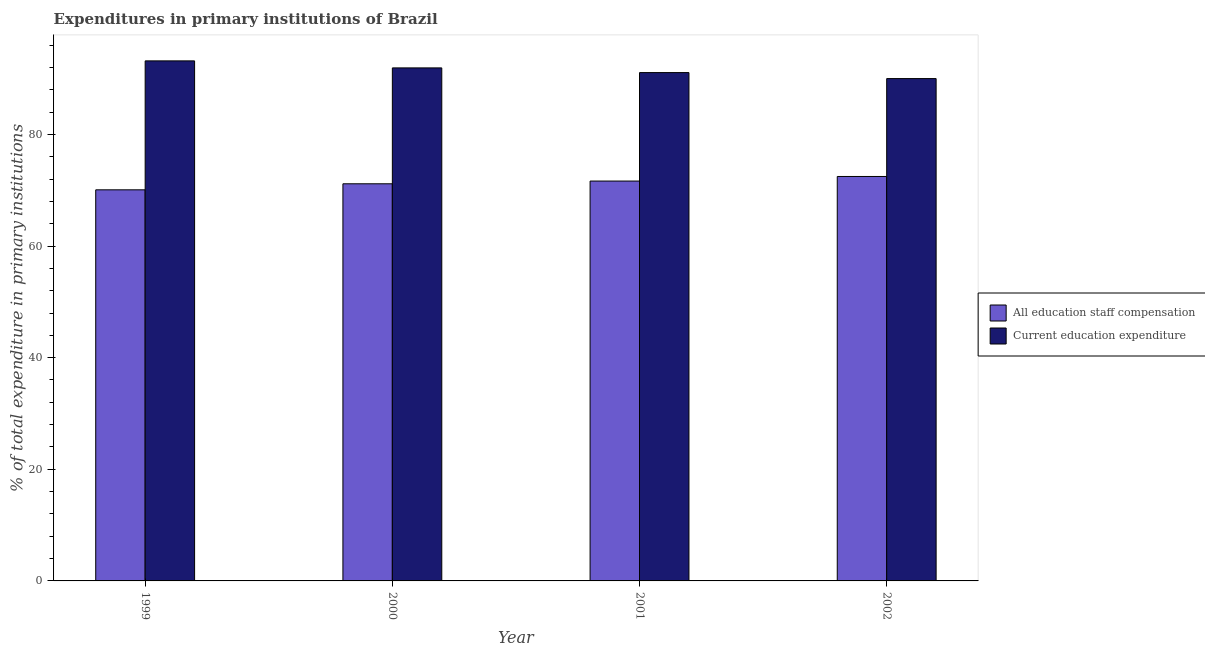Are the number of bars on each tick of the X-axis equal?
Keep it short and to the point. Yes. How many bars are there on the 3rd tick from the left?
Make the answer very short. 2. What is the expenditure in staff compensation in 2001?
Provide a short and direct response. 71.64. Across all years, what is the maximum expenditure in staff compensation?
Offer a terse response. 72.46. Across all years, what is the minimum expenditure in staff compensation?
Provide a short and direct response. 70.07. What is the total expenditure in education in the graph?
Make the answer very short. 366.17. What is the difference between the expenditure in staff compensation in 1999 and that in 2001?
Your answer should be very brief. -1.57. What is the difference between the expenditure in education in 2001 and the expenditure in staff compensation in 2002?
Give a very brief answer. 1.07. What is the average expenditure in education per year?
Provide a succinct answer. 91.54. In the year 2001, what is the difference between the expenditure in staff compensation and expenditure in education?
Your response must be concise. 0. In how many years, is the expenditure in staff compensation greater than 32 %?
Your answer should be very brief. 4. What is the ratio of the expenditure in education in 2000 to that in 2001?
Make the answer very short. 1.01. Is the expenditure in staff compensation in 1999 less than that in 2001?
Your answer should be very brief. Yes. What is the difference between the highest and the second highest expenditure in education?
Give a very brief answer. 1.26. What is the difference between the highest and the lowest expenditure in staff compensation?
Offer a very short reply. 2.39. What does the 1st bar from the left in 1999 represents?
Give a very brief answer. All education staff compensation. What does the 1st bar from the right in 2002 represents?
Your answer should be compact. Current education expenditure. Are all the bars in the graph horizontal?
Provide a short and direct response. No. What is the difference between two consecutive major ticks on the Y-axis?
Your answer should be compact. 20. Does the graph contain any zero values?
Provide a short and direct response. No. How many legend labels are there?
Give a very brief answer. 2. How are the legend labels stacked?
Your answer should be compact. Vertical. What is the title of the graph?
Provide a succinct answer. Expenditures in primary institutions of Brazil. What is the label or title of the Y-axis?
Your response must be concise. % of total expenditure in primary institutions. What is the % of total expenditure in primary institutions of All education staff compensation in 1999?
Your answer should be very brief. 70.07. What is the % of total expenditure in primary institutions of Current education expenditure in 1999?
Keep it short and to the point. 93.18. What is the % of total expenditure in primary institutions in All education staff compensation in 2000?
Provide a succinct answer. 71.15. What is the % of total expenditure in primary institutions of Current education expenditure in 2000?
Give a very brief answer. 91.92. What is the % of total expenditure in primary institutions of All education staff compensation in 2001?
Your answer should be very brief. 71.64. What is the % of total expenditure in primary institutions of Current education expenditure in 2001?
Your response must be concise. 91.08. What is the % of total expenditure in primary institutions in All education staff compensation in 2002?
Offer a very short reply. 72.46. What is the % of total expenditure in primary institutions of Current education expenditure in 2002?
Make the answer very short. 90. Across all years, what is the maximum % of total expenditure in primary institutions of All education staff compensation?
Provide a short and direct response. 72.46. Across all years, what is the maximum % of total expenditure in primary institutions of Current education expenditure?
Provide a short and direct response. 93.18. Across all years, what is the minimum % of total expenditure in primary institutions of All education staff compensation?
Offer a terse response. 70.07. Across all years, what is the minimum % of total expenditure in primary institutions of Current education expenditure?
Provide a short and direct response. 90. What is the total % of total expenditure in primary institutions of All education staff compensation in the graph?
Ensure brevity in your answer.  285.34. What is the total % of total expenditure in primary institutions of Current education expenditure in the graph?
Keep it short and to the point. 366.17. What is the difference between the % of total expenditure in primary institutions in All education staff compensation in 1999 and that in 2000?
Ensure brevity in your answer.  -1.08. What is the difference between the % of total expenditure in primary institutions of Current education expenditure in 1999 and that in 2000?
Provide a short and direct response. 1.26. What is the difference between the % of total expenditure in primary institutions in All education staff compensation in 1999 and that in 2001?
Your answer should be very brief. -1.57. What is the difference between the % of total expenditure in primary institutions of Current education expenditure in 1999 and that in 2001?
Give a very brief answer. 2.1. What is the difference between the % of total expenditure in primary institutions in All education staff compensation in 1999 and that in 2002?
Offer a terse response. -2.39. What is the difference between the % of total expenditure in primary institutions in Current education expenditure in 1999 and that in 2002?
Provide a succinct answer. 3.17. What is the difference between the % of total expenditure in primary institutions in All education staff compensation in 2000 and that in 2001?
Offer a very short reply. -0.49. What is the difference between the % of total expenditure in primary institutions in Current education expenditure in 2000 and that in 2001?
Ensure brevity in your answer.  0.84. What is the difference between the % of total expenditure in primary institutions in All education staff compensation in 2000 and that in 2002?
Provide a succinct answer. -1.31. What is the difference between the % of total expenditure in primary institutions of Current education expenditure in 2000 and that in 2002?
Keep it short and to the point. 1.91. What is the difference between the % of total expenditure in primary institutions of All education staff compensation in 2001 and that in 2002?
Your response must be concise. -0.82. What is the difference between the % of total expenditure in primary institutions in Current education expenditure in 2001 and that in 2002?
Provide a short and direct response. 1.07. What is the difference between the % of total expenditure in primary institutions of All education staff compensation in 1999 and the % of total expenditure in primary institutions of Current education expenditure in 2000?
Provide a succinct answer. -21.84. What is the difference between the % of total expenditure in primary institutions in All education staff compensation in 1999 and the % of total expenditure in primary institutions in Current education expenditure in 2001?
Your answer should be compact. -21. What is the difference between the % of total expenditure in primary institutions in All education staff compensation in 1999 and the % of total expenditure in primary institutions in Current education expenditure in 2002?
Provide a succinct answer. -19.93. What is the difference between the % of total expenditure in primary institutions in All education staff compensation in 2000 and the % of total expenditure in primary institutions in Current education expenditure in 2001?
Provide a succinct answer. -19.92. What is the difference between the % of total expenditure in primary institutions of All education staff compensation in 2000 and the % of total expenditure in primary institutions of Current education expenditure in 2002?
Provide a succinct answer. -18.85. What is the difference between the % of total expenditure in primary institutions of All education staff compensation in 2001 and the % of total expenditure in primary institutions of Current education expenditure in 2002?
Your answer should be compact. -18.36. What is the average % of total expenditure in primary institutions of All education staff compensation per year?
Provide a short and direct response. 71.33. What is the average % of total expenditure in primary institutions in Current education expenditure per year?
Your response must be concise. 91.54. In the year 1999, what is the difference between the % of total expenditure in primary institutions of All education staff compensation and % of total expenditure in primary institutions of Current education expenditure?
Your answer should be compact. -23.1. In the year 2000, what is the difference between the % of total expenditure in primary institutions of All education staff compensation and % of total expenditure in primary institutions of Current education expenditure?
Give a very brief answer. -20.76. In the year 2001, what is the difference between the % of total expenditure in primary institutions of All education staff compensation and % of total expenditure in primary institutions of Current education expenditure?
Offer a terse response. -19.43. In the year 2002, what is the difference between the % of total expenditure in primary institutions in All education staff compensation and % of total expenditure in primary institutions in Current education expenditure?
Make the answer very short. -17.54. What is the ratio of the % of total expenditure in primary institutions of Current education expenditure in 1999 to that in 2000?
Give a very brief answer. 1.01. What is the ratio of the % of total expenditure in primary institutions of All education staff compensation in 1999 to that in 2001?
Your answer should be very brief. 0.98. What is the ratio of the % of total expenditure in primary institutions in Current education expenditure in 1999 to that in 2001?
Provide a short and direct response. 1.02. What is the ratio of the % of total expenditure in primary institutions of Current education expenditure in 1999 to that in 2002?
Give a very brief answer. 1.04. What is the ratio of the % of total expenditure in primary institutions of All education staff compensation in 2000 to that in 2001?
Your response must be concise. 0.99. What is the ratio of the % of total expenditure in primary institutions of Current education expenditure in 2000 to that in 2001?
Keep it short and to the point. 1.01. What is the ratio of the % of total expenditure in primary institutions of All education staff compensation in 2000 to that in 2002?
Provide a succinct answer. 0.98. What is the ratio of the % of total expenditure in primary institutions of Current education expenditure in 2000 to that in 2002?
Give a very brief answer. 1.02. What is the ratio of the % of total expenditure in primary institutions of All education staff compensation in 2001 to that in 2002?
Your answer should be compact. 0.99. What is the ratio of the % of total expenditure in primary institutions in Current education expenditure in 2001 to that in 2002?
Offer a very short reply. 1.01. What is the difference between the highest and the second highest % of total expenditure in primary institutions of All education staff compensation?
Ensure brevity in your answer.  0.82. What is the difference between the highest and the second highest % of total expenditure in primary institutions in Current education expenditure?
Your answer should be compact. 1.26. What is the difference between the highest and the lowest % of total expenditure in primary institutions of All education staff compensation?
Your answer should be compact. 2.39. What is the difference between the highest and the lowest % of total expenditure in primary institutions of Current education expenditure?
Give a very brief answer. 3.17. 